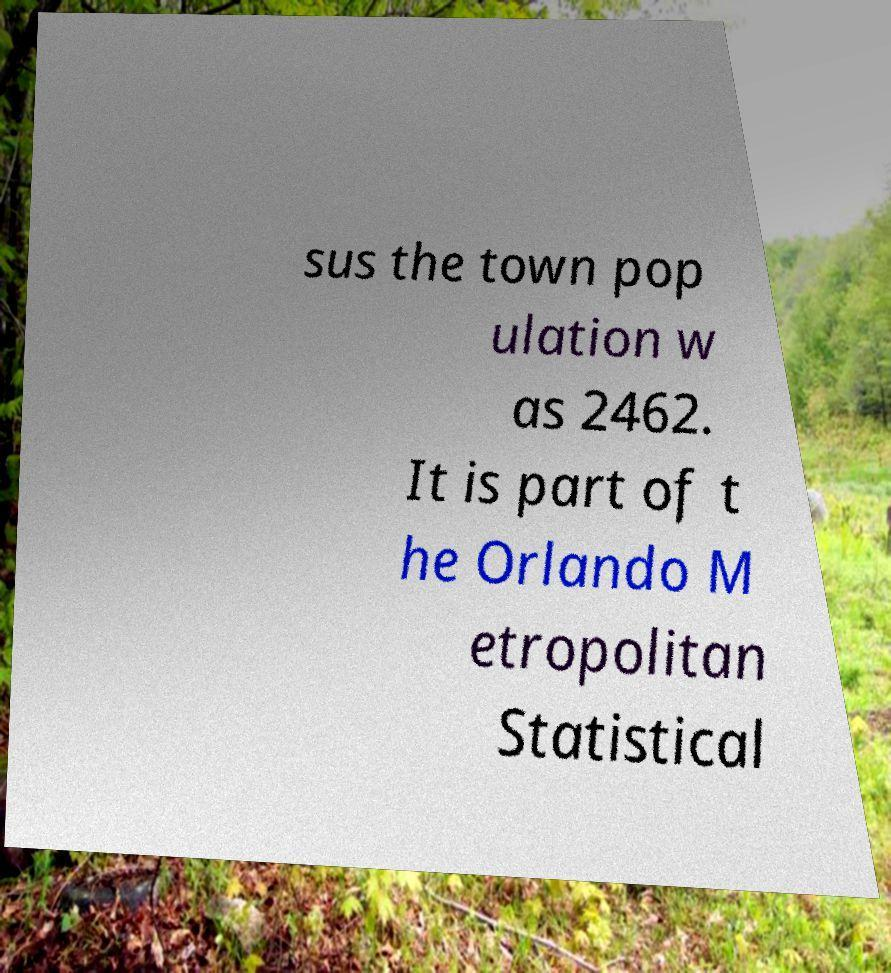Could you assist in decoding the text presented in this image and type it out clearly? sus the town pop ulation w as 2462. It is part of t he Orlando M etropolitan Statistical 